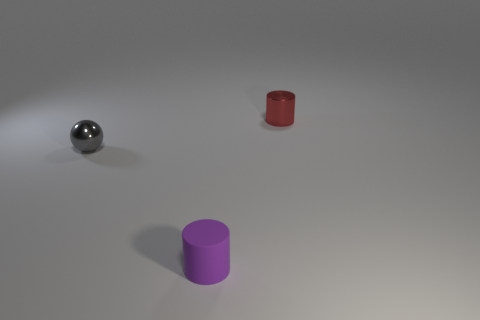How many things are tiny things behind the small metallic ball or small objects to the left of the red object?
Ensure brevity in your answer.  3. The small thing that is to the right of the tiny rubber thing has what shape?
Ensure brevity in your answer.  Cylinder. There is a small purple matte thing that is left of the small red metallic thing; is it the same shape as the small gray thing?
Give a very brief answer. No. How many objects are either small things that are behind the tiny gray metallic object or small things?
Ensure brevity in your answer.  3. There is another small object that is the same shape as the tiny purple matte object; what is its color?
Make the answer very short. Red. Are there any other things that are the same color as the tiny sphere?
Give a very brief answer. No. There is a object in front of the gray metallic sphere; how big is it?
Provide a succinct answer. Small. Is the color of the metallic cylinder the same as the tiny object to the left of the purple cylinder?
Keep it short and to the point. No. What number of other things are there of the same material as the ball
Offer a very short reply. 1. Are there more small rubber cylinders than yellow metallic cylinders?
Your answer should be very brief. Yes. 